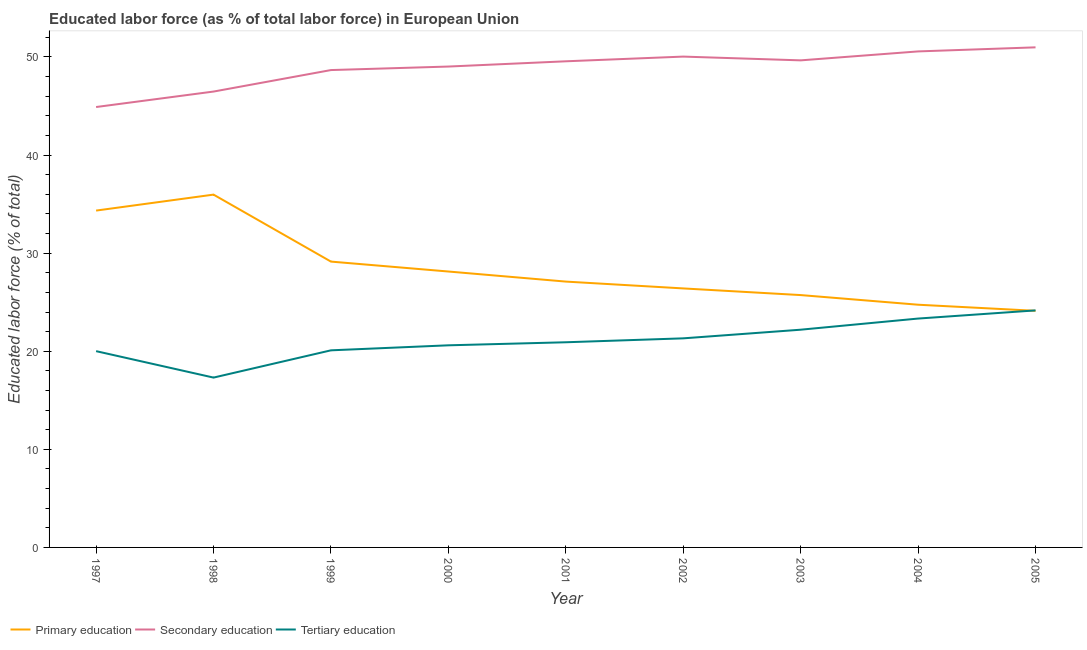How many different coloured lines are there?
Offer a terse response. 3. Is the number of lines equal to the number of legend labels?
Ensure brevity in your answer.  Yes. What is the percentage of labor force who received primary education in 1998?
Give a very brief answer. 35.97. Across all years, what is the maximum percentage of labor force who received tertiary education?
Your answer should be very brief. 24.16. Across all years, what is the minimum percentage of labor force who received primary education?
Offer a very short reply. 24.12. In which year was the percentage of labor force who received primary education maximum?
Offer a very short reply. 1998. What is the total percentage of labor force who received primary education in the graph?
Your answer should be very brief. 255.67. What is the difference between the percentage of labor force who received primary education in 2000 and that in 2001?
Keep it short and to the point. 1.03. What is the difference between the percentage of labor force who received secondary education in 1997 and the percentage of labor force who received primary education in 2002?
Your answer should be very brief. 18.49. What is the average percentage of labor force who received tertiary education per year?
Your response must be concise. 21.11. In the year 1999, what is the difference between the percentage of labor force who received secondary education and percentage of labor force who received tertiary education?
Make the answer very short. 28.57. What is the ratio of the percentage of labor force who received primary education in 1999 to that in 2000?
Give a very brief answer. 1.04. Is the difference between the percentage of labor force who received secondary education in 1999 and 2000 greater than the difference between the percentage of labor force who received primary education in 1999 and 2000?
Ensure brevity in your answer.  No. What is the difference between the highest and the second highest percentage of labor force who received secondary education?
Your response must be concise. 0.42. What is the difference between the highest and the lowest percentage of labor force who received secondary education?
Offer a terse response. 6.08. In how many years, is the percentage of labor force who received primary education greater than the average percentage of labor force who received primary education taken over all years?
Ensure brevity in your answer.  3. Is the sum of the percentage of labor force who received tertiary education in 1998 and 1999 greater than the maximum percentage of labor force who received secondary education across all years?
Offer a very short reply. No. Does the percentage of labor force who received secondary education monotonically increase over the years?
Keep it short and to the point. No. Is the percentage of labor force who received secondary education strictly greater than the percentage of labor force who received primary education over the years?
Your answer should be compact. Yes. Is the percentage of labor force who received primary education strictly less than the percentage of labor force who received secondary education over the years?
Make the answer very short. Yes. What is the difference between two consecutive major ticks on the Y-axis?
Give a very brief answer. 10. How many legend labels are there?
Ensure brevity in your answer.  3. How are the legend labels stacked?
Offer a very short reply. Horizontal. What is the title of the graph?
Make the answer very short. Educated labor force (as % of total labor force) in European Union. Does "Industrial Nitrous Oxide" appear as one of the legend labels in the graph?
Give a very brief answer. No. What is the label or title of the Y-axis?
Your response must be concise. Educated labor force (% of total). What is the Educated labor force (% of total) in Primary education in 1997?
Keep it short and to the point. 34.34. What is the Educated labor force (% of total) of Secondary education in 1997?
Your answer should be compact. 44.9. What is the Educated labor force (% of total) of Tertiary education in 1997?
Provide a short and direct response. 20.01. What is the Educated labor force (% of total) of Primary education in 1998?
Ensure brevity in your answer.  35.97. What is the Educated labor force (% of total) of Secondary education in 1998?
Provide a short and direct response. 46.47. What is the Educated labor force (% of total) in Tertiary education in 1998?
Ensure brevity in your answer.  17.31. What is the Educated labor force (% of total) of Primary education in 1999?
Your answer should be very brief. 29.14. What is the Educated labor force (% of total) in Secondary education in 1999?
Offer a terse response. 48.66. What is the Educated labor force (% of total) in Tertiary education in 1999?
Offer a very short reply. 20.09. What is the Educated labor force (% of total) in Primary education in 2000?
Your answer should be very brief. 28.13. What is the Educated labor force (% of total) of Secondary education in 2000?
Offer a terse response. 49.02. What is the Educated labor force (% of total) in Tertiary education in 2000?
Keep it short and to the point. 20.6. What is the Educated labor force (% of total) of Primary education in 2001?
Offer a very short reply. 27.1. What is the Educated labor force (% of total) in Secondary education in 2001?
Offer a very short reply. 49.56. What is the Educated labor force (% of total) of Tertiary education in 2001?
Your response must be concise. 20.92. What is the Educated labor force (% of total) of Primary education in 2002?
Offer a very short reply. 26.4. What is the Educated labor force (% of total) of Secondary education in 2002?
Offer a very short reply. 50.04. What is the Educated labor force (% of total) in Tertiary education in 2002?
Provide a succinct answer. 21.32. What is the Educated labor force (% of total) of Primary education in 2003?
Keep it short and to the point. 25.73. What is the Educated labor force (% of total) of Secondary education in 2003?
Provide a succinct answer. 49.65. What is the Educated labor force (% of total) in Tertiary education in 2003?
Ensure brevity in your answer.  22.2. What is the Educated labor force (% of total) of Primary education in 2004?
Ensure brevity in your answer.  24.74. What is the Educated labor force (% of total) in Secondary education in 2004?
Provide a short and direct response. 50.57. What is the Educated labor force (% of total) of Tertiary education in 2004?
Provide a succinct answer. 23.33. What is the Educated labor force (% of total) in Primary education in 2005?
Your answer should be compact. 24.12. What is the Educated labor force (% of total) of Secondary education in 2005?
Provide a short and direct response. 50.98. What is the Educated labor force (% of total) in Tertiary education in 2005?
Your answer should be compact. 24.16. Across all years, what is the maximum Educated labor force (% of total) in Primary education?
Give a very brief answer. 35.97. Across all years, what is the maximum Educated labor force (% of total) of Secondary education?
Offer a terse response. 50.98. Across all years, what is the maximum Educated labor force (% of total) in Tertiary education?
Ensure brevity in your answer.  24.16. Across all years, what is the minimum Educated labor force (% of total) in Primary education?
Your answer should be very brief. 24.12. Across all years, what is the minimum Educated labor force (% of total) of Secondary education?
Provide a short and direct response. 44.9. Across all years, what is the minimum Educated labor force (% of total) in Tertiary education?
Keep it short and to the point. 17.31. What is the total Educated labor force (% of total) in Primary education in the graph?
Offer a very short reply. 255.67. What is the total Educated labor force (% of total) of Secondary education in the graph?
Provide a short and direct response. 439.86. What is the total Educated labor force (% of total) in Tertiary education in the graph?
Make the answer very short. 189.95. What is the difference between the Educated labor force (% of total) in Primary education in 1997 and that in 1998?
Provide a short and direct response. -1.63. What is the difference between the Educated labor force (% of total) of Secondary education in 1997 and that in 1998?
Your answer should be very brief. -1.58. What is the difference between the Educated labor force (% of total) of Tertiary education in 1997 and that in 1998?
Provide a succinct answer. 2.69. What is the difference between the Educated labor force (% of total) in Primary education in 1997 and that in 1999?
Provide a short and direct response. 5.2. What is the difference between the Educated labor force (% of total) of Secondary education in 1997 and that in 1999?
Offer a very short reply. -3.77. What is the difference between the Educated labor force (% of total) of Tertiary education in 1997 and that in 1999?
Make the answer very short. -0.08. What is the difference between the Educated labor force (% of total) in Primary education in 1997 and that in 2000?
Provide a short and direct response. 6.21. What is the difference between the Educated labor force (% of total) in Secondary education in 1997 and that in 2000?
Your answer should be compact. -4.13. What is the difference between the Educated labor force (% of total) of Tertiary education in 1997 and that in 2000?
Your answer should be compact. -0.6. What is the difference between the Educated labor force (% of total) of Primary education in 1997 and that in 2001?
Keep it short and to the point. 7.24. What is the difference between the Educated labor force (% of total) in Secondary education in 1997 and that in 2001?
Offer a very short reply. -4.66. What is the difference between the Educated labor force (% of total) in Tertiary education in 1997 and that in 2001?
Your response must be concise. -0.91. What is the difference between the Educated labor force (% of total) in Primary education in 1997 and that in 2002?
Make the answer very short. 7.94. What is the difference between the Educated labor force (% of total) in Secondary education in 1997 and that in 2002?
Make the answer very short. -5.14. What is the difference between the Educated labor force (% of total) of Tertiary education in 1997 and that in 2002?
Provide a succinct answer. -1.31. What is the difference between the Educated labor force (% of total) in Primary education in 1997 and that in 2003?
Your answer should be compact. 8.61. What is the difference between the Educated labor force (% of total) of Secondary education in 1997 and that in 2003?
Offer a very short reply. -4.76. What is the difference between the Educated labor force (% of total) of Tertiary education in 1997 and that in 2003?
Your answer should be very brief. -2.19. What is the difference between the Educated labor force (% of total) in Primary education in 1997 and that in 2004?
Your response must be concise. 9.6. What is the difference between the Educated labor force (% of total) of Secondary education in 1997 and that in 2004?
Offer a terse response. -5.67. What is the difference between the Educated labor force (% of total) in Tertiary education in 1997 and that in 2004?
Make the answer very short. -3.32. What is the difference between the Educated labor force (% of total) of Primary education in 1997 and that in 2005?
Make the answer very short. 10.22. What is the difference between the Educated labor force (% of total) of Secondary education in 1997 and that in 2005?
Ensure brevity in your answer.  -6.08. What is the difference between the Educated labor force (% of total) of Tertiary education in 1997 and that in 2005?
Give a very brief answer. -4.16. What is the difference between the Educated labor force (% of total) of Primary education in 1998 and that in 1999?
Your answer should be very brief. 6.83. What is the difference between the Educated labor force (% of total) in Secondary education in 1998 and that in 1999?
Provide a succinct answer. -2.19. What is the difference between the Educated labor force (% of total) in Tertiary education in 1998 and that in 1999?
Offer a very short reply. -2.78. What is the difference between the Educated labor force (% of total) of Primary education in 1998 and that in 2000?
Keep it short and to the point. 7.84. What is the difference between the Educated labor force (% of total) in Secondary education in 1998 and that in 2000?
Make the answer very short. -2.55. What is the difference between the Educated labor force (% of total) in Tertiary education in 1998 and that in 2000?
Ensure brevity in your answer.  -3.29. What is the difference between the Educated labor force (% of total) in Primary education in 1998 and that in 2001?
Your response must be concise. 8.87. What is the difference between the Educated labor force (% of total) of Secondary education in 1998 and that in 2001?
Provide a succinct answer. -3.08. What is the difference between the Educated labor force (% of total) in Tertiary education in 1998 and that in 2001?
Make the answer very short. -3.6. What is the difference between the Educated labor force (% of total) of Primary education in 1998 and that in 2002?
Give a very brief answer. 9.56. What is the difference between the Educated labor force (% of total) of Secondary education in 1998 and that in 2002?
Make the answer very short. -3.56. What is the difference between the Educated labor force (% of total) in Tertiary education in 1998 and that in 2002?
Your answer should be compact. -4. What is the difference between the Educated labor force (% of total) of Primary education in 1998 and that in 2003?
Provide a succinct answer. 10.24. What is the difference between the Educated labor force (% of total) of Secondary education in 1998 and that in 2003?
Your answer should be compact. -3.18. What is the difference between the Educated labor force (% of total) of Tertiary education in 1998 and that in 2003?
Keep it short and to the point. -4.88. What is the difference between the Educated labor force (% of total) of Primary education in 1998 and that in 2004?
Provide a succinct answer. 11.22. What is the difference between the Educated labor force (% of total) in Secondary education in 1998 and that in 2004?
Your response must be concise. -4.09. What is the difference between the Educated labor force (% of total) in Tertiary education in 1998 and that in 2004?
Your answer should be compact. -6.02. What is the difference between the Educated labor force (% of total) in Primary education in 1998 and that in 2005?
Provide a short and direct response. 11.85. What is the difference between the Educated labor force (% of total) of Secondary education in 1998 and that in 2005?
Offer a terse response. -4.51. What is the difference between the Educated labor force (% of total) in Tertiary education in 1998 and that in 2005?
Keep it short and to the point. -6.85. What is the difference between the Educated labor force (% of total) in Primary education in 1999 and that in 2000?
Provide a succinct answer. 1.01. What is the difference between the Educated labor force (% of total) in Secondary education in 1999 and that in 2000?
Make the answer very short. -0.36. What is the difference between the Educated labor force (% of total) of Tertiary education in 1999 and that in 2000?
Your answer should be very brief. -0.51. What is the difference between the Educated labor force (% of total) in Primary education in 1999 and that in 2001?
Offer a terse response. 2.04. What is the difference between the Educated labor force (% of total) in Secondary education in 1999 and that in 2001?
Make the answer very short. -0.89. What is the difference between the Educated labor force (% of total) of Tertiary education in 1999 and that in 2001?
Provide a short and direct response. -0.82. What is the difference between the Educated labor force (% of total) of Primary education in 1999 and that in 2002?
Give a very brief answer. 2.74. What is the difference between the Educated labor force (% of total) in Secondary education in 1999 and that in 2002?
Keep it short and to the point. -1.37. What is the difference between the Educated labor force (% of total) of Tertiary education in 1999 and that in 2002?
Your answer should be very brief. -1.22. What is the difference between the Educated labor force (% of total) in Primary education in 1999 and that in 2003?
Ensure brevity in your answer.  3.41. What is the difference between the Educated labor force (% of total) in Secondary education in 1999 and that in 2003?
Give a very brief answer. -0.99. What is the difference between the Educated labor force (% of total) in Tertiary education in 1999 and that in 2003?
Offer a terse response. -2.1. What is the difference between the Educated labor force (% of total) in Primary education in 1999 and that in 2004?
Keep it short and to the point. 4.4. What is the difference between the Educated labor force (% of total) of Secondary education in 1999 and that in 2004?
Ensure brevity in your answer.  -1.9. What is the difference between the Educated labor force (% of total) of Tertiary education in 1999 and that in 2004?
Your answer should be very brief. -3.24. What is the difference between the Educated labor force (% of total) of Primary education in 1999 and that in 2005?
Offer a terse response. 5.02. What is the difference between the Educated labor force (% of total) in Secondary education in 1999 and that in 2005?
Your response must be concise. -2.32. What is the difference between the Educated labor force (% of total) of Tertiary education in 1999 and that in 2005?
Provide a succinct answer. -4.07. What is the difference between the Educated labor force (% of total) of Primary education in 2000 and that in 2001?
Your answer should be compact. 1.03. What is the difference between the Educated labor force (% of total) in Secondary education in 2000 and that in 2001?
Give a very brief answer. -0.54. What is the difference between the Educated labor force (% of total) of Tertiary education in 2000 and that in 2001?
Make the answer very short. -0.31. What is the difference between the Educated labor force (% of total) in Primary education in 2000 and that in 2002?
Your response must be concise. 1.72. What is the difference between the Educated labor force (% of total) in Secondary education in 2000 and that in 2002?
Provide a short and direct response. -1.01. What is the difference between the Educated labor force (% of total) of Tertiary education in 2000 and that in 2002?
Provide a succinct answer. -0.71. What is the difference between the Educated labor force (% of total) of Primary education in 2000 and that in 2003?
Give a very brief answer. 2.4. What is the difference between the Educated labor force (% of total) of Secondary education in 2000 and that in 2003?
Ensure brevity in your answer.  -0.63. What is the difference between the Educated labor force (% of total) in Tertiary education in 2000 and that in 2003?
Your answer should be very brief. -1.59. What is the difference between the Educated labor force (% of total) in Primary education in 2000 and that in 2004?
Your answer should be very brief. 3.38. What is the difference between the Educated labor force (% of total) in Secondary education in 2000 and that in 2004?
Your response must be concise. -1.54. What is the difference between the Educated labor force (% of total) in Tertiary education in 2000 and that in 2004?
Your answer should be very brief. -2.73. What is the difference between the Educated labor force (% of total) of Primary education in 2000 and that in 2005?
Give a very brief answer. 4.01. What is the difference between the Educated labor force (% of total) in Secondary education in 2000 and that in 2005?
Offer a very short reply. -1.96. What is the difference between the Educated labor force (% of total) of Tertiary education in 2000 and that in 2005?
Your answer should be very brief. -3.56. What is the difference between the Educated labor force (% of total) of Primary education in 2001 and that in 2002?
Make the answer very short. 0.7. What is the difference between the Educated labor force (% of total) in Secondary education in 2001 and that in 2002?
Provide a short and direct response. -0.48. What is the difference between the Educated labor force (% of total) of Tertiary education in 2001 and that in 2002?
Your answer should be compact. -0.4. What is the difference between the Educated labor force (% of total) of Primary education in 2001 and that in 2003?
Provide a succinct answer. 1.38. What is the difference between the Educated labor force (% of total) in Secondary education in 2001 and that in 2003?
Make the answer very short. -0.1. What is the difference between the Educated labor force (% of total) of Tertiary education in 2001 and that in 2003?
Keep it short and to the point. -1.28. What is the difference between the Educated labor force (% of total) of Primary education in 2001 and that in 2004?
Make the answer very short. 2.36. What is the difference between the Educated labor force (% of total) of Secondary education in 2001 and that in 2004?
Make the answer very short. -1.01. What is the difference between the Educated labor force (% of total) in Tertiary education in 2001 and that in 2004?
Give a very brief answer. -2.42. What is the difference between the Educated labor force (% of total) of Primary education in 2001 and that in 2005?
Your answer should be compact. 2.98. What is the difference between the Educated labor force (% of total) of Secondary education in 2001 and that in 2005?
Provide a short and direct response. -1.42. What is the difference between the Educated labor force (% of total) of Tertiary education in 2001 and that in 2005?
Offer a very short reply. -3.25. What is the difference between the Educated labor force (% of total) of Primary education in 2002 and that in 2003?
Keep it short and to the point. 0.68. What is the difference between the Educated labor force (% of total) of Secondary education in 2002 and that in 2003?
Your response must be concise. 0.38. What is the difference between the Educated labor force (% of total) in Tertiary education in 2002 and that in 2003?
Provide a short and direct response. -0.88. What is the difference between the Educated labor force (% of total) of Primary education in 2002 and that in 2004?
Offer a very short reply. 1.66. What is the difference between the Educated labor force (% of total) of Secondary education in 2002 and that in 2004?
Provide a short and direct response. -0.53. What is the difference between the Educated labor force (% of total) of Tertiary education in 2002 and that in 2004?
Your answer should be compact. -2.02. What is the difference between the Educated labor force (% of total) in Primary education in 2002 and that in 2005?
Your response must be concise. 2.28. What is the difference between the Educated labor force (% of total) in Secondary education in 2002 and that in 2005?
Offer a terse response. -0.94. What is the difference between the Educated labor force (% of total) of Tertiary education in 2002 and that in 2005?
Provide a succinct answer. -2.85. What is the difference between the Educated labor force (% of total) in Primary education in 2003 and that in 2004?
Offer a very short reply. 0.98. What is the difference between the Educated labor force (% of total) in Secondary education in 2003 and that in 2004?
Ensure brevity in your answer.  -0.91. What is the difference between the Educated labor force (% of total) in Tertiary education in 2003 and that in 2004?
Ensure brevity in your answer.  -1.14. What is the difference between the Educated labor force (% of total) in Primary education in 2003 and that in 2005?
Your answer should be compact. 1.6. What is the difference between the Educated labor force (% of total) in Secondary education in 2003 and that in 2005?
Make the answer very short. -1.33. What is the difference between the Educated labor force (% of total) in Tertiary education in 2003 and that in 2005?
Your answer should be very brief. -1.97. What is the difference between the Educated labor force (% of total) of Primary education in 2004 and that in 2005?
Your answer should be compact. 0.62. What is the difference between the Educated labor force (% of total) of Secondary education in 2004 and that in 2005?
Provide a succinct answer. -0.42. What is the difference between the Educated labor force (% of total) in Tertiary education in 2004 and that in 2005?
Offer a very short reply. -0.83. What is the difference between the Educated labor force (% of total) of Primary education in 1997 and the Educated labor force (% of total) of Secondary education in 1998?
Your response must be concise. -12.13. What is the difference between the Educated labor force (% of total) in Primary education in 1997 and the Educated labor force (% of total) in Tertiary education in 1998?
Your response must be concise. 17.03. What is the difference between the Educated labor force (% of total) of Secondary education in 1997 and the Educated labor force (% of total) of Tertiary education in 1998?
Offer a terse response. 27.58. What is the difference between the Educated labor force (% of total) of Primary education in 1997 and the Educated labor force (% of total) of Secondary education in 1999?
Your answer should be very brief. -14.32. What is the difference between the Educated labor force (% of total) in Primary education in 1997 and the Educated labor force (% of total) in Tertiary education in 1999?
Keep it short and to the point. 14.25. What is the difference between the Educated labor force (% of total) of Secondary education in 1997 and the Educated labor force (% of total) of Tertiary education in 1999?
Make the answer very short. 24.8. What is the difference between the Educated labor force (% of total) in Primary education in 1997 and the Educated labor force (% of total) in Secondary education in 2000?
Offer a terse response. -14.68. What is the difference between the Educated labor force (% of total) of Primary education in 1997 and the Educated labor force (% of total) of Tertiary education in 2000?
Your answer should be very brief. 13.74. What is the difference between the Educated labor force (% of total) of Secondary education in 1997 and the Educated labor force (% of total) of Tertiary education in 2000?
Keep it short and to the point. 24.29. What is the difference between the Educated labor force (% of total) of Primary education in 1997 and the Educated labor force (% of total) of Secondary education in 2001?
Your answer should be compact. -15.22. What is the difference between the Educated labor force (% of total) in Primary education in 1997 and the Educated labor force (% of total) in Tertiary education in 2001?
Provide a succinct answer. 13.42. What is the difference between the Educated labor force (% of total) in Secondary education in 1997 and the Educated labor force (% of total) in Tertiary education in 2001?
Offer a very short reply. 23.98. What is the difference between the Educated labor force (% of total) of Primary education in 1997 and the Educated labor force (% of total) of Secondary education in 2002?
Offer a terse response. -15.7. What is the difference between the Educated labor force (% of total) in Primary education in 1997 and the Educated labor force (% of total) in Tertiary education in 2002?
Your response must be concise. 13.02. What is the difference between the Educated labor force (% of total) of Secondary education in 1997 and the Educated labor force (% of total) of Tertiary education in 2002?
Ensure brevity in your answer.  23.58. What is the difference between the Educated labor force (% of total) of Primary education in 1997 and the Educated labor force (% of total) of Secondary education in 2003?
Keep it short and to the point. -15.31. What is the difference between the Educated labor force (% of total) in Primary education in 1997 and the Educated labor force (% of total) in Tertiary education in 2003?
Your response must be concise. 12.14. What is the difference between the Educated labor force (% of total) of Secondary education in 1997 and the Educated labor force (% of total) of Tertiary education in 2003?
Your answer should be compact. 22.7. What is the difference between the Educated labor force (% of total) of Primary education in 1997 and the Educated labor force (% of total) of Secondary education in 2004?
Offer a terse response. -16.23. What is the difference between the Educated labor force (% of total) of Primary education in 1997 and the Educated labor force (% of total) of Tertiary education in 2004?
Provide a succinct answer. 11.01. What is the difference between the Educated labor force (% of total) of Secondary education in 1997 and the Educated labor force (% of total) of Tertiary education in 2004?
Your answer should be compact. 21.57. What is the difference between the Educated labor force (% of total) in Primary education in 1997 and the Educated labor force (% of total) in Secondary education in 2005?
Offer a terse response. -16.64. What is the difference between the Educated labor force (% of total) of Primary education in 1997 and the Educated labor force (% of total) of Tertiary education in 2005?
Make the answer very short. 10.18. What is the difference between the Educated labor force (% of total) of Secondary education in 1997 and the Educated labor force (% of total) of Tertiary education in 2005?
Provide a succinct answer. 20.73. What is the difference between the Educated labor force (% of total) of Primary education in 1998 and the Educated labor force (% of total) of Secondary education in 1999?
Your answer should be compact. -12.7. What is the difference between the Educated labor force (% of total) of Primary education in 1998 and the Educated labor force (% of total) of Tertiary education in 1999?
Offer a very short reply. 15.87. What is the difference between the Educated labor force (% of total) of Secondary education in 1998 and the Educated labor force (% of total) of Tertiary education in 1999?
Keep it short and to the point. 26.38. What is the difference between the Educated labor force (% of total) in Primary education in 1998 and the Educated labor force (% of total) in Secondary education in 2000?
Give a very brief answer. -13.06. What is the difference between the Educated labor force (% of total) of Primary education in 1998 and the Educated labor force (% of total) of Tertiary education in 2000?
Your answer should be compact. 15.36. What is the difference between the Educated labor force (% of total) of Secondary education in 1998 and the Educated labor force (% of total) of Tertiary education in 2000?
Your answer should be very brief. 25.87. What is the difference between the Educated labor force (% of total) in Primary education in 1998 and the Educated labor force (% of total) in Secondary education in 2001?
Provide a succinct answer. -13.59. What is the difference between the Educated labor force (% of total) of Primary education in 1998 and the Educated labor force (% of total) of Tertiary education in 2001?
Your answer should be compact. 15.05. What is the difference between the Educated labor force (% of total) of Secondary education in 1998 and the Educated labor force (% of total) of Tertiary education in 2001?
Offer a very short reply. 25.56. What is the difference between the Educated labor force (% of total) of Primary education in 1998 and the Educated labor force (% of total) of Secondary education in 2002?
Your response must be concise. -14.07. What is the difference between the Educated labor force (% of total) in Primary education in 1998 and the Educated labor force (% of total) in Tertiary education in 2002?
Your response must be concise. 14.65. What is the difference between the Educated labor force (% of total) of Secondary education in 1998 and the Educated labor force (% of total) of Tertiary education in 2002?
Ensure brevity in your answer.  25.16. What is the difference between the Educated labor force (% of total) in Primary education in 1998 and the Educated labor force (% of total) in Secondary education in 2003?
Ensure brevity in your answer.  -13.69. What is the difference between the Educated labor force (% of total) of Primary education in 1998 and the Educated labor force (% of total) of Tertiary education in 2003?
Provide a succinct answer. 13.77. What is the difference between the Educated labor force (% of total) in Secondary education in 1998 and the Educated labor force (% of total) in Tertiary education in 2003?
Your answer should be compact. 24.28. What is the difference between the Educated labor force (% of total) of Primary education in 1998 and the Educated labor force (% of total) of Secondary education in 2004?
Give a very brief answer. -14.6. What is the difference between the Educated labor force (% of total) of Primary education in 1998 and the Educated labor force (% of total) of Tertiary education in 2004?
Provide a succinct answer. 12.64. What is the difference between the Educated labor force (% of total) in Secondary education in 1998 and the Educated labor force (% of total) in Tertiary education in 2004?
Your answer should be very brief. 23.14. What is the difference between the Educated labor force (% of total) of Primary education in 1998 and the Educated labor force (% of total) of Secondary education in 2005?
Make the answer very short. -15.01. What is the difference between the Educated labor force (% of total) in Primary education in 1998 and the Educated labor force (% of total) in Tertiary education in 2005?
Provide a succinct answer. 11.8. What is the difference between the Educated labor force (% of total) in Secondary education in 1998 and the Educated labor force (% of total) in Tertiary education in 2005?
Offer a very short reply. 22.31. What is the difference between the Educated labor force (% of total) in Primary education in 1999 and the Educated labor force (% of total) in Secondary education in 2000?
Provide a short and direct response. -19.88. What is the difference between the Educated labor force (% of total) in Primary education in 1999 and the Educated labor force (% of total) in Tertiary education in 2000?
Provide a succinct answer. 8.53. What is the difference between the Educated labor force (% of total) of Secondary education in 1999 and the Educated labor force (% of total) of Tertiary education in 2000?
Make the answer very short. 28.06. What is the difference between the Educated labor force (% of total) of Primary education in 1999 and the Educated labor force (% of total) of Secondary education in 2001?
Provide a succinct answer. -20.42. What is the difference between the Educated labor force (% of total) in Primary education in 1999 and the Educated labor force (% of total) in Tertiary education in 2001?
Offer a very short reply. 8.22. What is the difference between the Educated labor force (% of total) of Secondary education in 1999 and the Educated labor force (% of total) of Tertiary education in 2001?
Keep it short and to the point. 27.75. What is the difference between the Educated labor force (% of total) in Primary education in 1999 and the Educated labor force (% of total) in Secondary education in 2002?
Offer a very short reply. -20.9. What is the difference between the Educated labor force (% of total) in Primary education in 1999 and the Educated labor force (% of total) in Tertiary education in 2002?
Give a very brief answer. 7.82. What is the difference between the Educated labor force (% of total) in Secondary education in 1999 and the Educated labor force (% of total) in Tertiary education in 2002?
Ensure brevity in your answer.  27.35. What is the difference between the Educated labor force (% of total) in Primary education in 1999 and the Educated labor force (% of total) in Secondary education in 2003?
Ensure brevity in your answer.  -20.52. What is the difference between the Educated labor force (% of total) in Primary education in 1999 and the Educated labor force (% of total) in Tertiary education in 2003?
Provide a short and direct response. 6.94. What is the difference between the Educated labor force (% of total) in Secondary education in 1999 and the Educated labor force (% of total) in Tertiary education in 2003?
Ensure brevity in your answer.  26.47. What is the difference between the Educated labor force (% of total) in Primary education in 1999 and the Educated labor force (% of total) in Secondary education in 2004?
Your answer should be compact. -21.43. What is the difference between the Educated labor force (% of total) in Primary education in 1999 and the Educated labor force (% of total) in Tertiary education in 2004?
Your answer should be compact. 5.81. What is the difference between the Educated labor force (% of total) of Secondary education in 1999 and the Educated labor force (% of total) of Tertiary education in 2004?
Make the answer very short. 25.33. What is the difference between the Educated labor force (% of total) of Primary education in 1999 and the Educated labor force (% of total) of Secondary education in 2005?
Your response must be concise. -21.84. What is the difference between the Educated labor force (% of total) in Primary education in 1999 and the Educated labor force (% of total) in Tertiary education in 2005?
Keep it short and to the point. 4.97. What is the difference between the Educated labor force (% of total) of Secondary education in 1999 and the Educated labor force (% of total) of Tertiary education in 2005?
Offer a terse response. 24.5. What is the difference between the Educated labor force (% of total) of Primary education in 2000 and the Educated labor force (% of total) of Secondary education in 2001?
Offer a terse response. -21.43. What is the difference between the Educated labor force (% of total) in Primary education in 2000 and the Educated labor force (% of total) in Tertiary education in 2001?
Make the answer very short. 7.21. What is the difference between the Educated labor force (% of total) in Secondary education in 2000 and the Educated labor force (% of total) in Tertiary education in 2001?
Your response must be concise. 28.11. What is the difference between the Educated labor force (% of total) in Primary education in 2000 and the Educated labor force (% of total) in Secondary education in 2002?
Offer a terse response. -21.91. What is the difference between the Educated labor force (% of total) in Primary education in 2000 and the Educated labor force (% of total) in Tertiary education in 2002?
Offer a very short reply. 6.81. What is the difference between the Educated labor force (% of total) in Secondary education in 2000 and the Educated labor force (% of total) in Tertiary education in 2002?
Offer a terse response. 27.71. What is the difference between the Educated labor force (% of total) in Primary education in 2000 and the Educated labor force (% of total) in Secondary education in 2003?
Keep it short and to the point. -21.53. What is the difference between the Educated labor force (% of total) in Primary education in 2000 and the Educated labor force (% of total) in Tertiary education in 2003?
Ensure brevity in your answer.  5.93. What is the difference between the Educated labor force (% of total) in Secondary education in 2000 and the Educated labor force (% of total) in Tertiary education in 2003?
Make the answer very short. 26.83. What is the difference between the Educated labor force (% of total) in Primary education in 2000 and the Educated labor force (% of total) in Secondary education in 2004?
Ensure brevity in your answer.  -22.44. What is the difference between the Educated labor force (% of total) in Primary education in 2000 and the Educated labor force (% of total) in Tertiary education in 2004?
Your answer should be very brief. 4.8. What is the difference between the Educated labor force (% of total) in Secondary education in 2000 and the Educated labor force (% of total) in Tertiary education in 2004?
Your answer should be very brief. 25.69. What is the difference between the Educated labor force (% of total) in Primary education in 2000 and the Educated labor force (% of total) in Secondary education in 2005?
Offer a terse response. -22.85. What is the difference between the Educated labor force (% of total) in Primary education in 2000 and the Educated labor force (% of total) in Tertiary education in 2005?
Your response must be concise. 3.96. What is the difference between the Educated labor force (% of total) of Secondary education in 2000 and the Educated labor force (% of total) of Tertiary education in 2005?
Your response must be concise. 24.86. What is the difference between the Educated labor force (% of total) in Primary education in 2001 and the Educated labor force (% of total) in Secondary education in 2002?
Make the answer very short. -22.94. What is the difference between the Educated labor force (% of total) in Primary education in 2001 and the Educated labor force (% of total) in Tertiary education in 2002?
Ensure brevity in your answer.  5.79. What is the difference between the Educated labor force (% of total) of Secondary education in 2001 and the Educated labor force (% of total) of Tertiary education in 2002?
Give a very brief answer. 28.24. What is the difference between the Educated labor force (% of total) in Primary education in 2001 and the Educated labor force (% of total) in Secondary education in 2003?
Your response must be concise. -22.55. What is the difference between the Educated labor force (% of total) in Primary education in 2001 and the Educated labor force (% of total) in Tertiary education in 2003?
Offer a terse response. 4.9. What is the difference between the Educated labor force (% of total) in Secondary education in 2001 and the Educated labor force (% of total) in Tertiary education in 2003?
Your answer should be compact. 27.36. What is the difference between the Educated labor force (% of total) of Primary education in 2001 and the Educated labor force (% of total) of Secondary education in 2004?
Your answer should be compact. -23.46. What is the difference between the Educated labor force (% of total) of Primary education in 2001 and the Educated labor force (% of total) of Tertiary education in 2004?
Your response must be concise. 3.77. What is the difference between the Educated labor force (% of total) of Secondary education in 2001 and the Educated labor force (% of total) of Tertiary education in 2004?
Your response must be concise. 26.23. What is the difference between the Educated labor force (% of total) of Primary education in 2001 and the Educated labor force (% of total) of Secondary education in 2005?
Give a very brief answer. -23.88. What is the difference between the Educated labor force (% of total) of Primary education in 2001 and the Educated labor force (% of total) of Tertiary education in 2005?
Offer a very short reply. 2.94. What is the difference between the Educated labor force (% of total) in Secondary education in 2001 and the Educated labor force (% of total) in Tertiary education in 2005?
Your answer should be compact. 25.39. What is the difference between the Educated labor force (% of total) in Primary education in 2002 and the Educated labor force (% of total) in Secondary education in 2003?
Provide a succinct answer. -23.25. What is the difference between the Educated labor force (% of total) of Primary education in 2002 and the Educated labor force (% of total) of Tertiary education in 2003?
Offer a very short reply. 4.21. What is the difference between the Educated labor force (% of total) in Secondary education in 2002 and the Educated labor force (% of total) in Tertiary education in 2003?
Provide a short and direct response. 27.84. What is the difference between the Educated labor force (% of total) in Primary education in 2002 and the Educated labor force (% of total) in Secondary education in 2004?
Offer a terse response. -24.16. What is the difference between the Educated labor force (% of total) of Primary education in 2002 and the Educated labor force (% of total) of Tertiary education in 2004?
Provide a succinct answer. 3.07. What is the difference between the Educated labor force (% of total) of Secondary education in 2002 and the Educated labor force (% of total) of Tertiary education in 2004?
Keep it short and to the point. 26.71. What is the difference between the Educated labor force (% of total) in Primary education in 2002 and the Educated labor force (% of total) in Secondary education in 2005?
Give a very brief answer. -24.58. What is the difference between the Educated labor force (% of total) of Primary education in 2002 and the Educated labor force (% of total) of Tertiary education in 2005?
Your answer should be compact. 2.24. What is the difference between the Educated labor force (% of total) in Secondary education in 2002 and the Educated labor force (% of total) in Tertiary education in 2005?
Provide a succinct answer. 25.87. What is the difference between the Educated labor force (% of total) of Primary education in 2003 and the Educated labor force (% of total) of Secondary education in 2004?
Ensure brevity in your answer.  -24.84. What is the difference between the Educated labor force (% of total) in Primary education in 2003 and the Educated labor force (% of total) in Tertiary education in 2004?
Provide a short and direct response. 2.39. What is the difference between the Educated labor force (% of total) in Secondary education in 2003 and the Educated labor force (% of total) in Tertiary education in 2004?
Your response must be concise. 26.32. What is the difference between the Educated labor force (% of total) of Primary education in 2003 and the Educated labor force (% of total) of Secondary education in 2005?
Your answer should be compact. -25.26. What is the difference between the Educated labor force (% of total) in Primary education in 2003 and the Educated labor force (% of total) in Tertiary education in 2005?
Provide a succinct answer. 1.56. What is the difference between the Educated labor force (% of total) of Secondary education in 2003 and the Educated labor force (% of total) of Tertiary education in 2005?
Offer a very short reply. 25.49. What is the difference between the Educated labor force (% of total) in Primary education in 2004 and the Educated labor force (% of total) in Secondary education in 2005?
Your answer should be compact. -26.24. What is the difference between the Educated labor force (% of total) in Primary education in 2004 and the Educated labor force (% of total) in Tertiary education in 2005?
Ensure brevity in your answer.  0.58. What is the difference between the Educated labor force (% of total) of Secondary education in 2004 and the Educated labor force (% of total) of Tertiary education in 2005?
Ensure brevity in your answer.  26.4. What is the average Educated labor force (% of total) in Primary education per year?
Ensure brevity in your answer.  28.41. What is the average Educated labor force (% of total) of Secondary education per year?
Your answer should be compact. 48.87. What is the average Educated labor force (% of total) of Tertiary education per year?
Ensure brevity in your answer.  21.11. In the year 1997, what is the difference between the Educated labor force (% of total) of Primary education and Educated labor force (% of total) of Secondary education?
Your answer should be very brief. -10.56. In the year 1997, what is the difference between the Educated labor force (% of total) of Primary education and Educated labor force (% of total) of Tertiary education?
Provide a succinct answer. 14.33. In the year 1997, what is the difference between the Educated labor force (% of total) of Secondary education and Educated labor force (% of total) of Tertiary education?
Provide a succinct answer. 24.89. In the year 1998, what is the difference between the Educated labor force (% of total) of Primary education and Educated labor force (% of total) of Secondary education?
Offer a very short reply. -10.51. In the year 1998, what is the difference between the Educated labor force (% of total) in Primary education and Educated labor force (% of total) in Tertiary education?
Keep it short and to the point. 18.65. In the year 1998, what is the difference between the Educated labor force (% of total) in Secondary education and Educated labor force (% of total) in Tertiary education?
Give a very brief answer. 29.16. In the year 1999, what is the difference between the Educated labor force (% of total) of Primary education and Educated labor force (% of total) of Secondary education?
Provide a succinct answer. -19.53. In the year 1999, what is the difference between the Educated labor force (% of total) in Primary education and Educated labor force (% of total) in Tertiary education?
Your answer should be compact. 9.05. In the year 1999, what is the difference between the Educated labor force (% of total) in Secondary education and Educated labor force (% of total) in Tertiary education?
Keep it short and to the point. 28.57. In the year 2000, what is the difference between the Educated labor force (% of total) of Primary education and Educated labor force (% of total) of Secondary education?
Your response must be concise. -20.9. In the year 2000, what is the difference between the Educated labor force (% of total) of Primary education and Educated labor force (% of total) of Tertiary education?
Offer a terse response. 7.52. In the year 2000, what is the difference between the Educated labor force (% of total) in Secondary education and Educated labor force (% of total) in Tertiary education?
Offer a very short reply. 28.42. In the year 2001, what is the difference between the Educated labor force (% of total) in Primary education and Educated labor force (% of total) in Secondary education?
Your answer should be very brief. -22.46. In the year 2001, what is the difference between the Educated labor force (% of total) of Primary education and Educated labor force (% of total) of Tertiary education?
Keep it short and to the point. 6.19. In the year 2001, what is the difference between the Educated labor force (% of total) in Secondary education and Educated labor force (% of total) in Tertiary education?
Give a very brief answer. 28.64. In the year 2002, what is the difference between the Educated labor force (% of total) of Primary education and Educated labor force (% of total) of Secondary education?
Ensure brevity in your answer.  -23.63. In the year 2002, what is the difference between the Educated labor force (% of total) in Primary education and Educated labor force (% of total) in Tertiary education?
Ensure brevity in your answer.  5.09. In the year 2002, what is the difference between the Educated labor force (% of total) in Secondary education and Educated labor force (% of total) in Tertiary education?
Make the answer very short. 28.72. In the year 2003, what is the difference between the Educated labor force (% of total) of Primary education and Educated labor force (% of total) of Secondary education?
Make the answer very short. -23.93. In the year 2003, what is the difference between the Educated labor force (% of total) in Primary education and Educated labor force (% of total) in Tertiary education?
Keep it short and to the point. 3.53. In the year 2003, what is the difference between the Educated labor force (% of total) of Secondary education and Educated labor force (% of total) of Tertiary education?
Offer a terse response. 27.46. In the year 2004, what is the difference between the Educated labor force (% of total) of Primary education and Educated labor force (% of total) of Secondary education?
Your answer should be very brief. -25.82. In the year 2004, what is the difference between the Educated labor force (% of total) of Primary education and Educated labor force (% of total) of Tertiary education?
Provide a succinct answer. 1.41. In the year 2004, what is the difference between the Educated labor force (% of total) of Secondary education and Educated labor force (% of total) of Tertiary education?
Your response must be concise. 27.23. In the year 2005, what is the difference between the Educated labor force (% of total) in Primary education and Educated labor force (% of total) in Secondary education?
Give a very brief answer. -26.86. In the year 2005, what is the difference between the Educated labor force (% of total) in Primary education and Educated labor force (% of total) in Tertiary education?
Ensure brevity in your answer.  -0.04. In the year 2005, what is the difference between the Educated labor force (% of total) of Secondary education and Educated labor force (% of total) of Tertiary education?
Your response must be concise. 26.82. What is the ratio of the Educated labor force (% of total) in Primary education in 1997 to that in 1998?
Provide a short and direct response. 0.95. What is the ratio of the Educated labor force (% of total) of Secondary education in 1997 to that in 1998?
Offer a terse response. 0.97. What is the ratio of the Educated labor force (% of total) in Tertiary education in 1997 to that in 1998?
Make the answer very short. 1.16. What is the ratio of the Educated labor force (% of total) in Primary education in 1997 to that in 1999?
Ensure brevity in your answer.  1.18. What is the ratio of the Educated labor force (% of total) in Secondary education in 1997 to that in 1999?
Keep it short and to the point. 0.92. What is the ratio of the Educated labor force (% of total) in Primary education in 1997 to that in 2000?
Your answer should be compact. 1.22. What is the ratio of the Educated labor force (% of total) in Secondary education in 1997 to that in 2000?
Provide a short and direct response. 0.92. What is the ratio of the Educated labor force (% of total) of Tertiary education in 1997 to that in 2000?
Provide a short and direct response. 0.97. What is the ratio of the Educated labor force (% of total) in Primary education in 1997 to that in 2001?
Make the answer very short. 1.27. What is the ratio of the Educated labor force (% of total) in Secondary education in 1997 to that in 2001?
Offer a terse response. 0.91. What is the ratio of the Educated labor force (% of total) of Tertiary education in 1997 to that in 2001?
Make the answer very short. 0.96. What is the ratio of the Educated labor force (% of total) in Primary education in 1997 to that in 2002?
Ensure brevity in your answer.  1.3. What is the ratio of the Educated labor force (% of total) in Secondary education in 1997 to that in 2002?
Offer a very short reply. 0.9. What is the ratio of the Educated labor force (% of total) in Tertiary education in 1997 to that in 2002?
Offer a terse response. 0.94. What is the ratio of the Educated labor force (% of total) in Primary education in 1997 to that in 2003?
Ensure brevity in your answer.  1.33. What is the ratio of the Educated labor force (% of total) in Secondary education in 1997 to that in 2003?
Make the answer very short. 0.9. What is the ratio of the Educated labor force (% of total) of Tertiary education in 1997 to that in 2003?
Ensure brevity in your answer.  0.9. What is the ratio of the Educated labor force (% of total) in Primary education in 1997 to that in 2004?
Keep it short and to the point. 1.39. What is the ratio of the Educated labor force (% of total) of Secondary education in 1997 to that in 2004?
Your response must be concise. 0.89. What is the ratio of the Educated labor force (% of total) of Tertiary education in 1997 to that in 2004?
Provide a short and direct response. 0.86. What is the ratio of the Educated labor force (% of total) of Primary education in 1997 to that in 2005?
Give a very brief answer. 1.42. What is the ratio of the Educated labor force (% of total) in Secondary education in 1997 to that in 2005?
Give a very brief answer. 0.88. What is the ratio of the Educated labor force (% of total) of Tertiary education in 1997 to that in 2005?
Provide a succinct answer. 0.83. What is the ratio of the Educated labor force (% of total) in Primary education in 1998 to that in 1999?
Your answer should be very brief. 1.23. What is the ratio of the Educated labor force (% of total) in Secondary education in 1998 to that in 1999?
Provide a succinct answer. 0.95. What is the ratio of the Educated labor force (% of total) of Tertiary education in 1998 to that in 1999?
Your answer should be compact. 0.86. What is the ratio of the Educated labor force (% of total) in Primary education in 1998 to that in 2000?
Provide a short and direct response. 1.28. What is the ratio of the Educated labor force (% of total) in Secondary education in 1998 to that in 2000?
Your answer should be very brief. 0.95. What is the ratio of the Educated labor force (% of total) in Tertiary education in 1998 to that in 2000?
Offer a terse response. 0.84. What is the ratio of the Educated labor force (% of total) of Primary education in 1998 to that in 2001?
Your answer should be very brief. 1.33. What is the ratio of the Educated labor force (% of total) of Secondary education in 1998 to that in 2001?
Ensure brevity in your answer.  0.94. What is the ratio of the Educated labor force (% of total) in Tertiary education in 1998 to that in 2001?
Make the answer very short. 0.83. What is the ratio of the Educated labor force (% of total) in Primary education in 1998 to that in 2002?
Ensure brevity in your answer.  1.36. What is the ratio of the Educated labor force (% of total) in Secondary education in 1998 to that in 2002?
Provide a short and direct response. 0.93. What is the ratio of the Educated labor force (% of total) of Tertiary education in 1998 to that in 2002?
Offer a very short reply. 0.81. What is the ratio of the Educated labor force (% of total) of Primary education in 1998 to that in 2003?
Keep it short and to the point. 1.4. What is the ratio of the Educated labor force (% of total) of Secondary education in 1998 to that in 2003?
Offer a terse response. 0.94. What is the ratio of the Educated labor force (% of total) in Tertiary education in 1998 to that in 2003?
Ensure brevity in your answer.  0.78. What is the ratio of the Educated labor force (% of total) in Primary education in 1998 to that in 2004?
Your answer should be compact. 1.45. What is the ratio of the Educated labor force (% of total) of Secondary education in 1998 to that in 2004?
Make the answer very short. 0.92. What is the ratio of the Educated labor force (% of total) in Tertiary education in 1998 to that in 2004?
Provide a short and direct response. 0.74. What is the ratio of the Educated labor force (% of total) in Primary education in 1998 to that in 2005?
Offer a very short reply. 1.49. What is the ratio of the Educated labor force (% of total) of Secondary education in 1998 to that in 2005?
Keep it short and to the point. 0.91. What is the ratio of the Educated labor force (% of total) of Tertiary education in 1998 to that in 2005?
Give a very brief answer. 0.72. What is the ratio of the Educated labor force (% of total) in Primary education in 1999 to that in 2000?
Give a very brief answer. 1.04. What is the ratio of the Educated labor force (% of total) in Tertiary education in 1999 to that in 2000?
Your answer should be compact. 0.98. What is the ratio of the Educated labor force (% of total) in Primary education in 1999 to that in 2001?
Make the answer very short. 1.08. What is the ratio of the Educated labor force (% of total) of Secondary education in 1999 to that in 2001?
Give a very brief answer. 0.98. What is the ratio of the Educated labor force (% of total) in Tertiary education in 1999 to that in 2001?
Keep it short and to the point. 0.96. What is the ratio of the Educated labor force (% of total) in Primary education in 1999 to that in 2002?
Provide a succinct answer. 1.1. What is the ratio of the Educated labor force (% of total) in Secondary education in 1999 to that in 2002?
Provide a short and direct response. 0.97. What is the ratio of the Educated labor force (% of total) of Tertiary education in 1999 to that in 2002?
Your answer should be very brief. 0.94. What is the ratio of the Educated labor force (% of total) in Primary education in 1999 to that in 2003?
Ensure brevity in your answer.  1.13. What is the ratio of the Educated labor force (% of total) in Secondary education in 1999 to that in 2003?
Your answer should be very brief. 0.98. What is the ratio of the Educated labor force (% of total) of Tertiary education in 1999 to that in 2003?
Your response must be concise. 0.91. What is the ratio of the Educated labor force (% of total) in Primary education in 1999 to that in 2004?
Provide a short and direct response. 1.18. What is the ratio of the Educated labor force (% of total) of Secondary education in 1999 to that in 2004?
Offer a very short reply. 0.96. What is the ratio of the Educated labor force (% of total) in Tertiary education in 1999 to that in 2004?
Provide a short and direct response. 0.86. What is the ratio of the Educated labor force (% of total) in Primary education in 1999 to that in 2005?
Provide a short and direct response. 1.21. What is the ratio of the Educated labor force (% of total) in Secondary education in 1999 to that in 2005?
Give a very brief answer. 0.95. What is the ratio of the Educated labor force (% of total) of Tertiary education in 1999 to that in 2005?
Your answer should be compact. 0.83. What is the ratio of the Educated labor force (% of total) of Primary education in 2000 to that in 2001?
Offer a very short reply. 1.04. What is the ratio of the Educated labor force (% of total) of Tertiary education in 2000 to that in 2001?
Provide a succinct answer. 0.99. What is the ratio of the Educated labor force (% of total) of Primary education in 2000 to that in 2002?
Give a very brief answer. 1.07. What is the ratio of the Educated labor force (% of total) of Secondary education in 2000 to that in 2002?
Your answer should be very brief. 0.98. What is the ratio of the Educated labor force (% of total) in Tertiary education in 2000 to that in 2002?
Your answer should be compact. 0.97. What is the ratio of the Educated labor force (% of total) in Primary education in 2000 to that in 2003?
Provide a succinct answer. 1.09. What is the ratio of the Educated labor force (% of total) in Secondary education in 2000 to that in 2003?
Your answer should be very brief. 0.99. What is the ratio of the Educated labor force (% of total) in Tertiary education in 2000 to that in 2003?
Your answer should be very brief. 0.93. What is the ratio of the Educated labor force (% of total) in Primary education in 2000 to that in 2004?
Ensure brevity in your answer.  1.14. What is the ratio of the Educated labor force (% of total) in Secondary education in 2000 to that in 2004?
Give a very brief answer. 0.97. What is the ratio of the Educated labor force (% of total) of Tertiary education in 2000 to that in 2004?
Your response must be concise. 0.88. What is the ratio of the Educated labor force (% of total) of Primary education in 2000 to that in 2005?
Your answer should be compact. 1.17. What is the ratio of the Educated labor force (% of total) in Secondary education in 2000 to that in 2005?
Provide a short and direct response. 0.96. What is the ratio of the Educated labor force (% of total) of Tertiary education in 2000 to that in 2005?
Offer a very short reply. 0.85. What is the ratio of the Educated labor force (% of total) of Primary education in 2001 to that in 2002?
Make the answer very short. 1.03. What is the ratio of the Educated labor force (% of total) in Secondary education in 2001 to that in 2002?
Ensure brevity in your answer.  0.99. What is the ratio of the Educated labor force (% of total) of Tertiary education in 2001 to that in 2002?
Give a very brief answer. 0.98. What is the ratio of the Educated labor force (% of total) in Primary education in 2001 to that in 2003?
Your answer should be compact. 1.05. What is the ratio of the Educated labor force (% of total) of Tertiary education in 2001 to that in 2003?
Your response must be concise. 0.94. What is the ratio of the Educated labor force (% of total) of Primary education in 2001 to that in 2004?
Provide a succinct answer. 1.1. What is the ratio of the Educated labor force (% of total) in Secondary education in 2001 to that in 2004?
Offer a very short reply. 0.98. What is the ratio of the Educated labor force (% of total) of Tertiary education in 2001 to that in 2004?
Your response must be concise. 0.9. What is the ratio of the Educated labor force (% of total) of Primary education in 2001 to that in 2005?
Your response must be concise. 1.12. What is the ratio of the Educated labor force (% of total) in Secondary education in 2001 to that in 2005?
Offer a very short reply. 0.97. What is the ratio of the Educated labor force (% of total) in Tertiary education in 2001 to that in 2005?
Give a very brief answer. 0.87. What is the ratio of the Educated labor force (% of total) in Primary education in 2002 to that in 2003?
Offer a terse response. 1.03. What is the ratio of the Educated labor force (% of total) in Secondary education in 2002 to that in 2003?
Keep it short and to the point. 1.01. What is the ratio of the Educated labor force (% of total) of Tertiary education in 2002 to that in 2003?
Provide a short and direct response. 0.96. What is the ratio of the Educated labor force (% of total) in Primary education in 2002 to that in 2004?
Provide a short and direct response. 1.07. What is the ratio of the Educated labor force (% of total) of Secondary education in 2002 to that in 2004?
Your answer should be compact. 0.99. What is the ratio of the Educated labor force (% of total) of Tertiary education in 2002 to that in 2004?
Your response must be concise. 0.91. What is the ratio of the Educated labor force (% of total) of Primary education in 2002 to that in 2005?
Make the answer very short. 1.09. What is the ratio of the Educated labor force (% of total) in Secondary education in 2002 to that in 2005?
Your answer should be very brief. 0.98. What is the ratio of the Educated labor force (% of total) in Tertiary education in 2002 to that in 2005?
Make the answer very short. 0.88. What is the ratio of the Educated labor force (% of total) of Primary education in 2003 to that in 2004?
Your answer should be compact. 1.04. What is the ratio of the Educated labor force (% of total) of Secondary education in 2003 to that in 2004?
Offer a terse response. 0.98. What is the ratio of the Educated labor force (% of total) in Tertiary education in 2003 to that in 2004?
Ensure brevity in your answer.  0.95. What is the ratio of the Educated labor force (% of total) of Primary education in 2003 to that in 2005?
Your answer should be compact. 1.07. What is the ratio of the Educated labor force (% of total) of Tertiary education in 2003 to that in 2005?
Ensure brevity in your answer.  0.92. What is the ratio of the Educated labor force (% of total) in Primary education in 2004 to that in 2005?
Give a very brief answer. 1.03. What is the ratio of the Educated labor force (% of total) in Tertiary education in 2004 to that in 2005?
Your answer should be compact. 0.97. What is the difference between the highest and the second highest Educated labor force (% of total) in Primary education?
Make the answer very short. 1.63. What is the difference between the highest and the second highest Educated labor force (% of total) in Secondary education?
Provide a short and direct response. 0.42. What is the difference between the highest and the second highest Educated labor force (% of total) of Tertiary education?
Keep it short and to the point. 0.83. What is the difference between the highest and the lowest Educated labor force (% of total) of Primary education?
Make the answer very short. 11.85. What is the difference between the highest and the lowest Educated labor force (% of total) in Secondary education?
Make the answer very short. 6.08. What is the difference between the highest and the lowest Educated labor force (% of total) of Tertiary education?
Offer a very short reply. 6.85. 